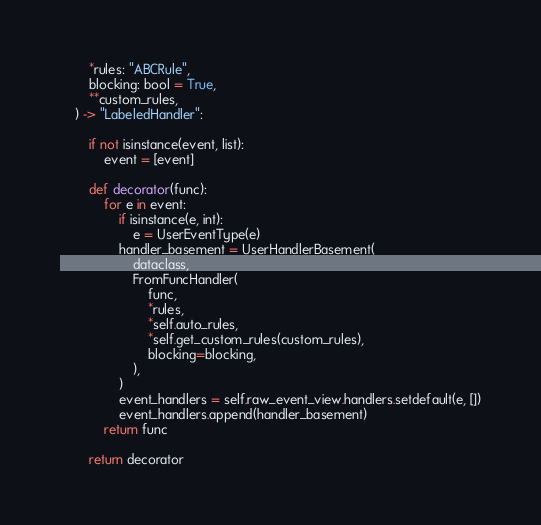Convert code to text. <code><loc_0><loc_0><loc_500><loc_500><_Python_>        *rules: "ABCRule",
        blocking: bool = True,
        **custom_rules,
    ) -> "LabeledHandler":

        if not isinstance(event, list):
            event = [event]

        def decorator(func):
            for e in event:
                if isinstance(e, int):
                    e = UserEventType(e)
                handler_basement = UserHandlerBasement(
                    dataclass,
                    FromFuncHandler(
                        func,
                        *rules,
                        *self.auto_rules,
                        *self.get_custom_rules(custom_rules),
                        blocking=blocking,
                    ),
                )
                event_handlers = self.raw_event_view.handlers.setdefault(e, [])
                event_handlers.append(handler_basement)
            return func

        return decorator
</code> 